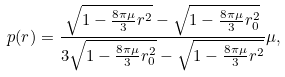<formula> <loc_0><loc_0><loc_500><loc_500>p ( r ) = \frac { \sqrt { 1 - \frac { 8 \pi \mu } { 3 } r ^ { 2 } } - \sqrt { 1 - \frac { 8 \pi \mu } { 3 } r _ { 0 } ^ { 2 } } } { 3 \sqrt { 1 - \frac { 8 \pi \mu } { 3 } r _ { 0 } ^ { 2 } } - \sqrt { 1 - \frac { 8 \pi \mu } { 3 } r ^ { 2 } } } \mu ,</formula> 